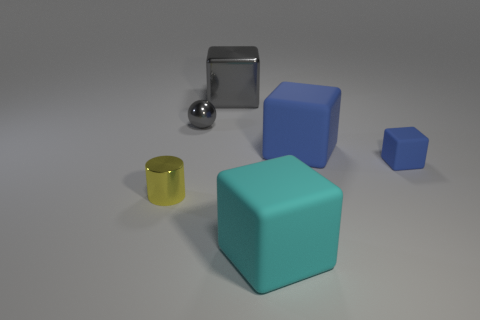There is a gray metal sphere behind the small blue cube; what is its size?
Your answer should be compact. Small. There is a tiny metallic object that is in front of the big cube on the right side of the cyan rubber object; how many tiny blue matte blocks are behind it?
Your answer should be compact. 1. There is a shiny ball; are there any cyan blocks in front of it?
Provide a short and direct response. Yes. What number of other objects are there of the same size as the yellow object?
Your answer should be very brief. 2. The small object that is both in front of the gray ball and to the left of the small blue matte thing is made of what material?
Your answer should be very brief. Metal. Does the large matte object to the right of the big cyan cube have the same shape as the tiny metal thing behind the small rubber block?
Keep it short and to the point. No. The gray thing that is on the left side of the cube that is left of the large object in front of the tiny yellow thing is what shape?
Your answer should be compact. Sphere. How many other objects are there of the same shape as the yellow metal object?
Your answer should be very brief. 0. What color is the block that is the same size as the gray ball?
Your answer should be compact. Blue. How many cubes are red rubber things or tiny rubber things?
Your answer should be very brief. 1. 